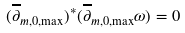Convert formula to latex. <formula><loc_0><loc_0><loc_500><loc_500>( \overline { \partial } _ { m , 0 , \max } ) ^ { * } ( \overline { \partial } _ { m , 0 , \max } \omega ) = 0</formula> 